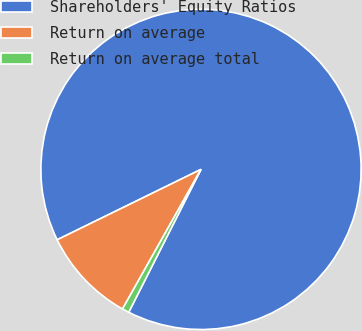<chart> <loc_0><loc_0><loc_500><loc_500><pie_chart><fcel>Shareholders' Equity Ratios<fcel>Return on average<fcel>Return on average total<nl><fcel>89.7%<fcel>9.6%<fcel>0.7%<nl></chart> 